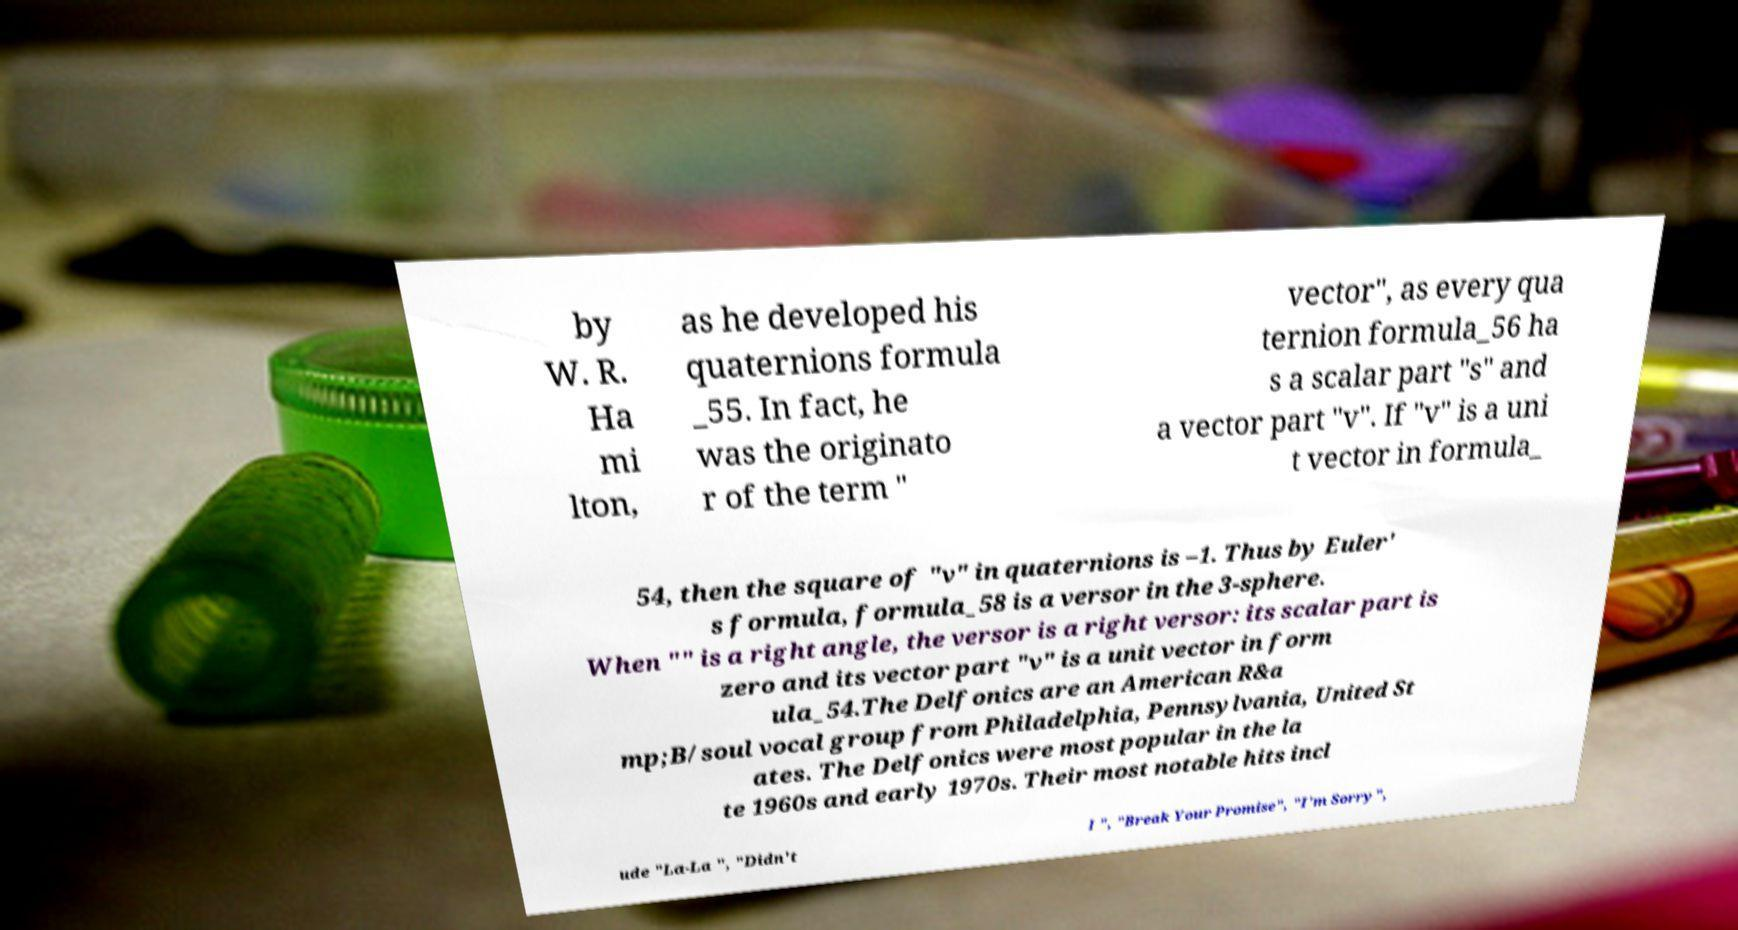There's text embedded in this image that I need extracted. Can you transcribe it verbatim? by W. R. Ha mi lton, as he developed his quaternions formula _55. In fact, he was the originato r of the term " vector", as every qua ternion formula_56 ha s a scalar part "s" and a vector part "v". If "v" is a uni t vector in formula_ 54, then the square of "v" in quaternions is –1. Thus by Euler' s formula, formula_58 is a versor in the 3-sphere. When "" is a right angle, the versor is a right versor: its scalar part is zero and its vector part "v" is a unit vector in form ula_54.The Delfonics are an American R&a mp;B/soul vocal group from Philadelphia, Pennsylvania, United St ates. The Delfonics were most popular in the la te 1960s and early 1970s. Their most notable hits incl ude "La-La ", "Didn't I ", "Break Your Promise", "I'm Sorry", 